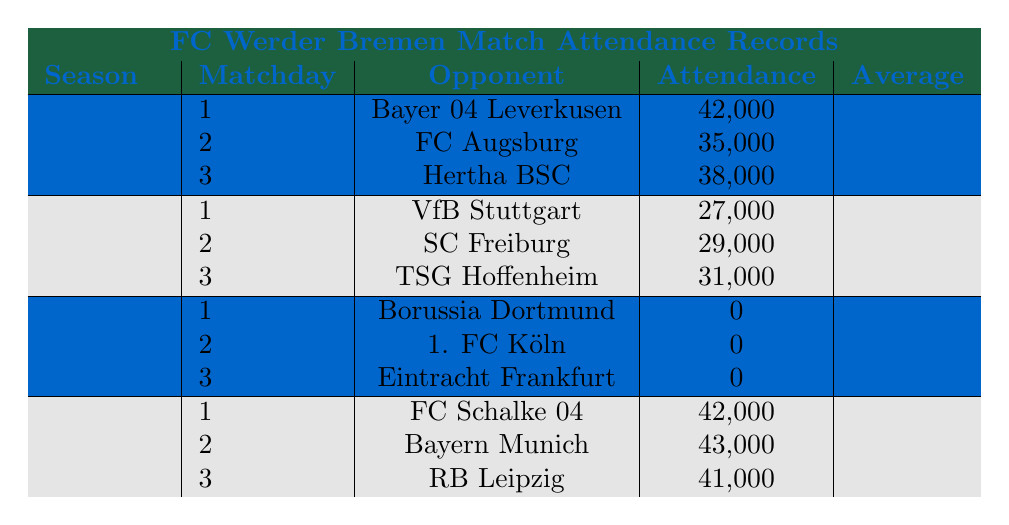What was the highest attendance recorded in the 2022-2023 season? To find the highest attendance in the 2022-2023 season, we look at the attendance figures listed for each match: 42,000 (Matchday 1), 35,000 (Matchday 2), and 38,000 (Matchday 3). The maximum of these values is 42,000.
Answer: 42,000 What is the average attendance for the 2019-2020 season? The average attendance for the 2019-2020 season is provided in the table as 42,000.
Answer: 42,000 Did FC Werder Bremen have any matches with attendance during the 2020-2021 season? In the 2020-2021 season, the attendance for all matches was recorded as 0 (Matchday 1: 0, Matchday 2: 0, Matchday 3: 0). Therefore, they did not have any matches with attendance.
Answer: No How many times did the attendance exceed 40,000 across all the seasons? We scan through each season and count the matches where attendance is above 40,000: in 2019-2020 (Matchday 1: 42,000, Matchday 2: 43,000, Matchday 3: 41,000) there are three instances above 40,000, and in 2022-2023, there's one instance (Matchday 1: 42,000). The total is four matches.
Answer: 4 What was the total attendance for all matches in the 2021-2022 season? We sum the attendance figures for the 2021-2022 season: 27,000 (Matchday 1) + 29,000 (Matchday 2) + 31,000 (Matchday 3) = 87,000.
Answer: 87,000 Was the average attendance in the 2021-2022 season lower than 30,000? The average attendance for the 2021-2022 season is provided in the table as 29,000, which is indeed lower than 30,000.
Answer: Yes Which match recorded the lowest attendance across all seasons? The lowest attendance recorded was 0 during all matches of the 2020-2021 season (Matchday 1: 0, Matchday 2: 0, Matchday 3: 0).
Answer: 0 What season had the highest average attendance? By reviewing the average attendance for each season, we see that the highest is 42,000 for the 2019-2020 season, compared to 39,667 (2022-2023), 29,000 (2021-2022), and 0 (2020-2021).
Answer: 2019-2020 